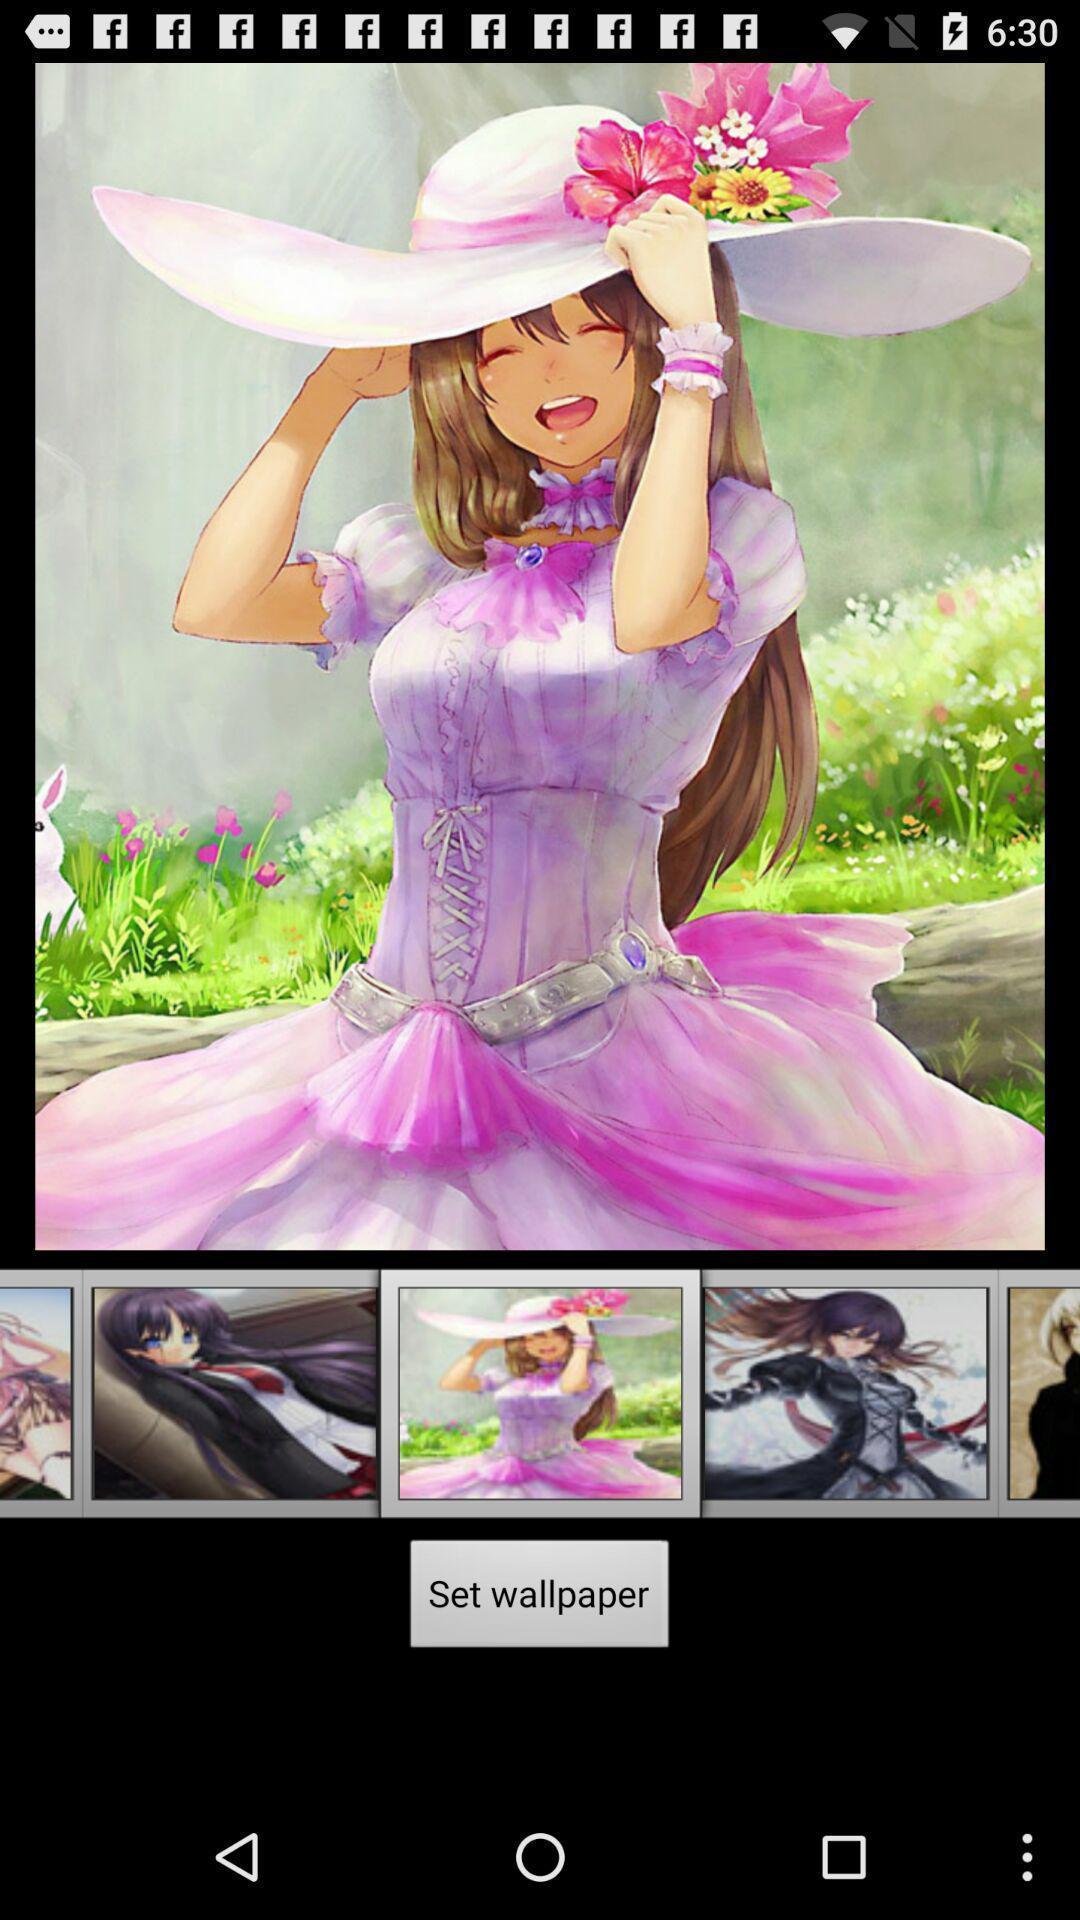What can you discern from this picture? Screen shows different images for wallpaper. 